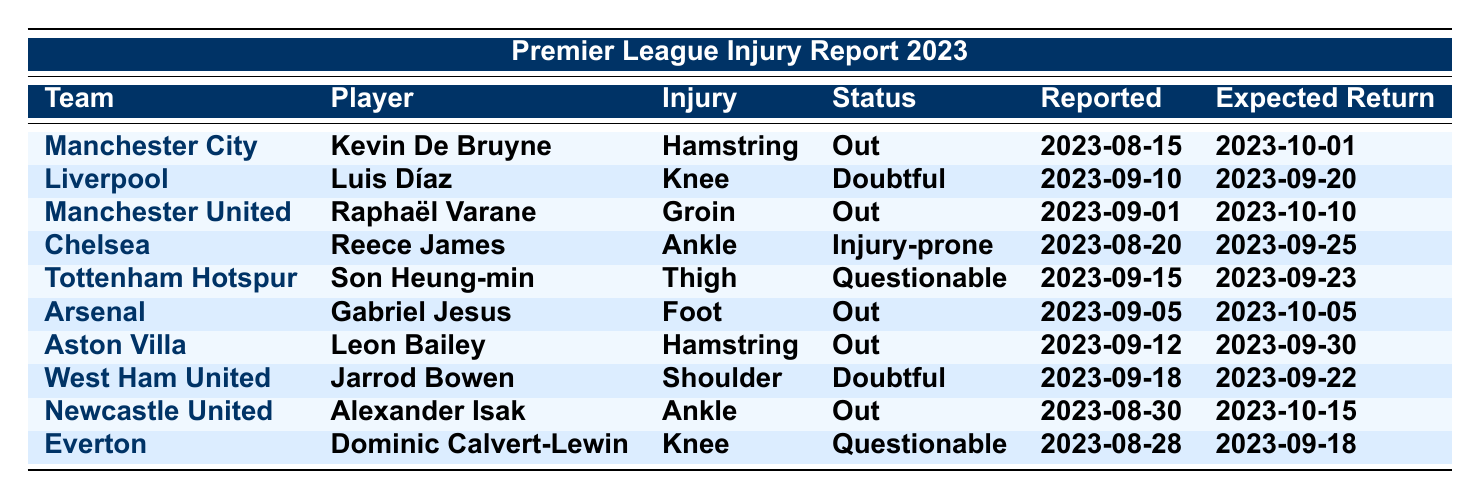What is the injury type for Kevin De Bruyne? In the table, Kevin De Bruyne is listed under Manchester City with an injury type of "Hamstring."
Answer: Hamstring Which player from Liverpool is listed as doubtful? The table indicates that Luis Díaz is the Liverpool player with a status of "Doubtful."
Answer: Luis Díaz How many players are out due to injuries? By reviewing the status column, the players currently listed as out are Kevin De Bruyne, Raphaël Varane, Gabriel Jesus, Leon Bailey, and Alexander Isak, totaling five players.
Answer: 5 What is the expected return date for Reece James? The table shows that Reece James is expected to return by 2023-09-25.
Answer: 2023-09-25 Is any player listed as injury-prone? Yes, Reece James from Chelsea is marked as "Injury-prone."
Answer: Yes Which team's player has a thigh injury? According to the table, Son Heung-min from Tottenham Hotspur has a thigh injury.
Answer: Son Heung-min What is the earliest reported injury date in the table? The earliest injury date among the players in the table is 2023-08-15, reported for Kevin De Bruyne.
Answer: 2023-08-15 Who is expected to return last from the reported injuries? Reviewing the expected return dates, Alexander Isak, expected back on 2023-10-15, has the latest expected return.
Answer: Alexander Isak Are there more players out or questionable due to injuries? The count based on the table shows six players are out (5) and three players are questionable (2), so there are more players out.
Answer: More players are out What is the status of Dominic Calvert-Lewin? The table states that Dominic Calvert-Lewin is marked as "Questionable" regarding his injury status.
Answer: Questionable Which team has the most players out? The table identifies Manchester United, Arsenal, and Newcastle United each having one player out, while others also have players out but doesn't exceed one; hence, there is no team with multiple players out.
Answer: None with multiple players out When was the latest reported injury in the table? The latest injury date reported is 2023-09-18 for Jarrod Bowen from West Ham United.
Answer: 2023-09-18 Which player has a knee injury? The table lists Luis Díaz from Liverpool and Dominic Calvert-Lewin from Everton as having knee injuries.
Answer: Luis Díaz and Dominic Calvert-Lewin What is the difference in expected return dates between Kevin De Bruyne and Gabriel Jesus? Kevin De Bruyne is expected to return on 2023-10-01 and Gabriel Jesus on 2023-10-05. The difference is four days.
Answer: 4 days Is there any player listed with a shoulder injury? Yes, Jarrod Bowen from West Ham United has a shoulder injury reported.
Answer: Yes 